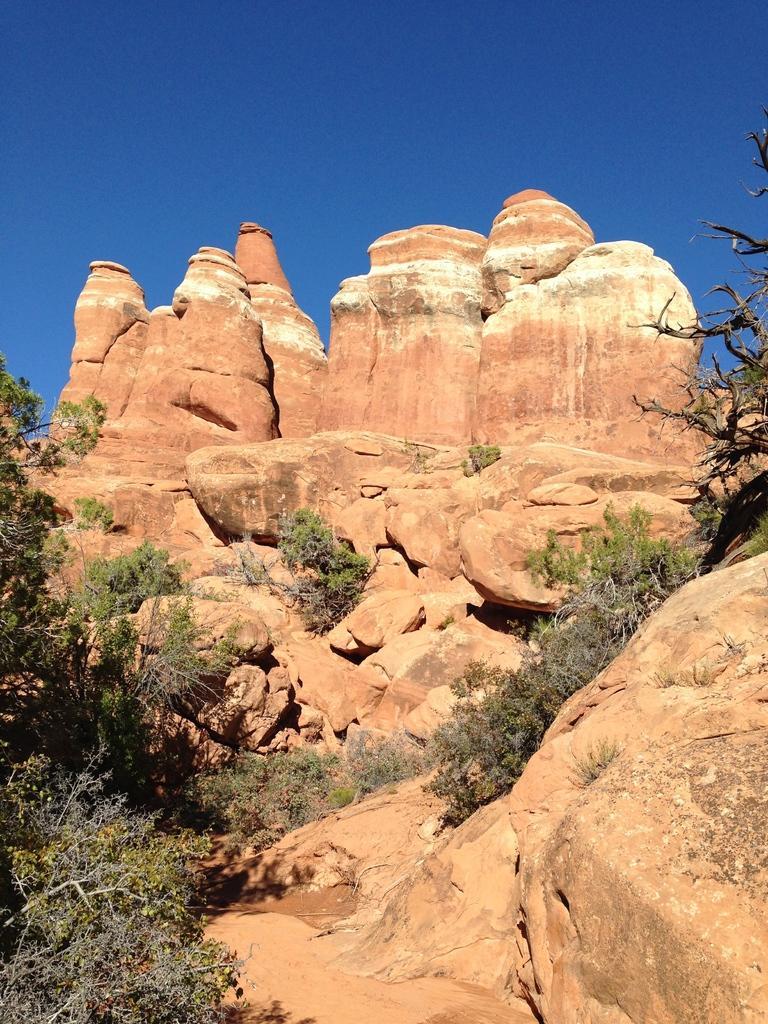Can you describe this image briefly? This looks like a hill with rocks. I can see the small plants and trees with branches and leaves. 